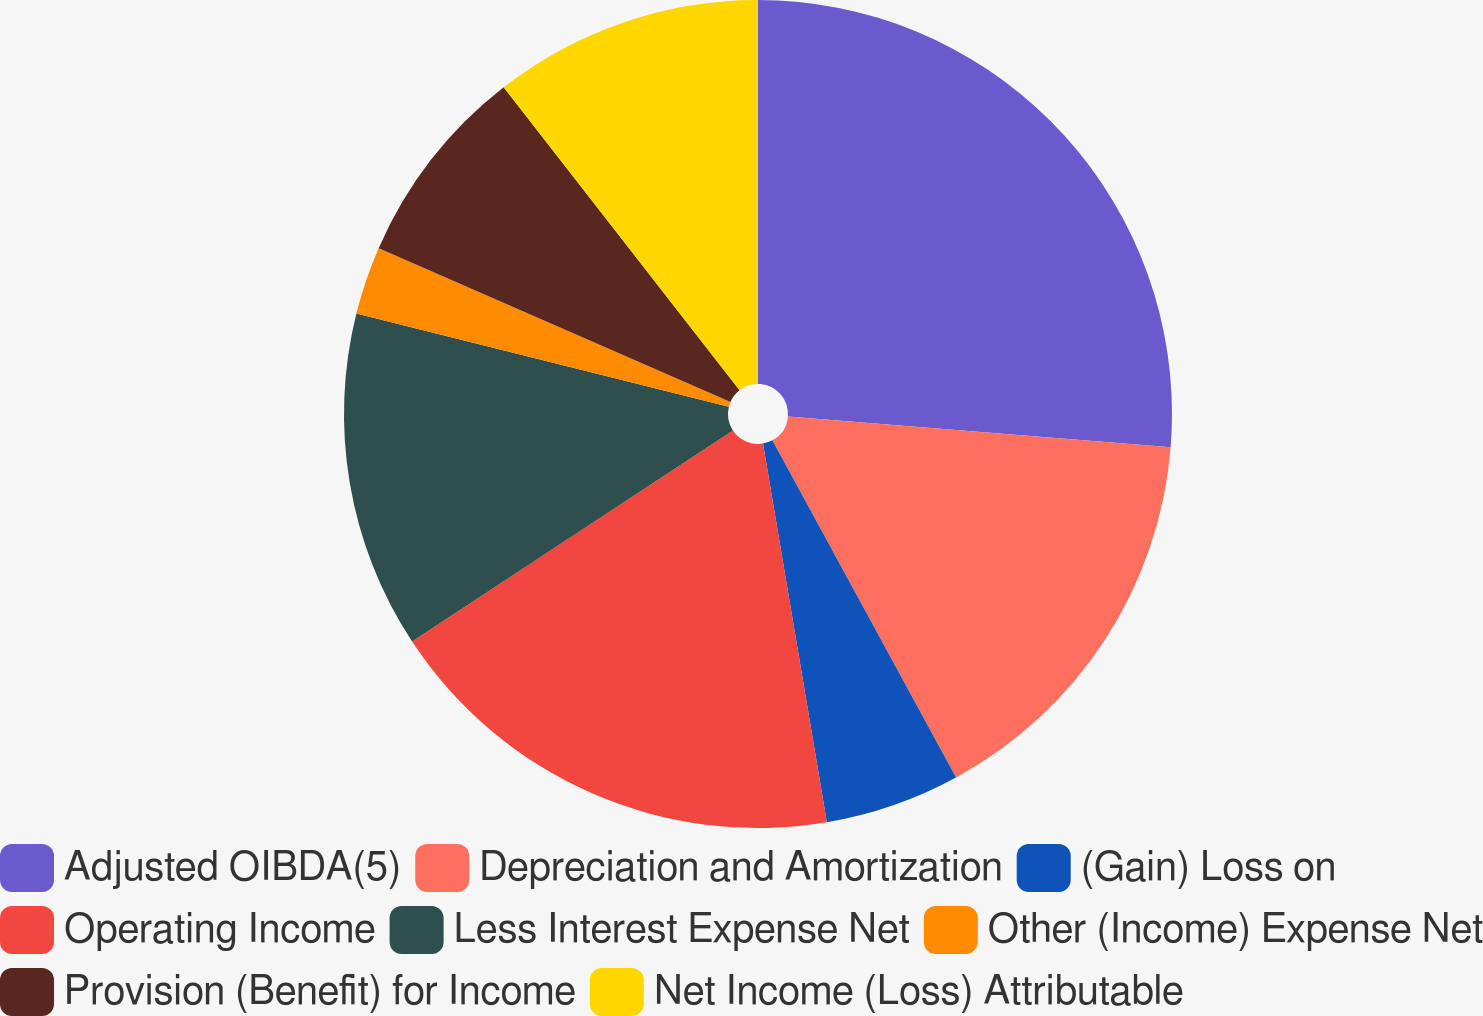<chart> <loc_0><loc_0><loc_500><loc_500><pie_chart><fcel>Adjusted OIBDA(5)<fcel>Depreciation and Amortization<fcel>(Gain) Loss on<fcel>Operating Income<fcel>Less Interest Expense Net<fcel>Other (Income) Expense Net<fcel>Provision (Benefit) for Income<fcel>Net Income (Loss) Attributable<nl><fcel>26.28%<fcel>15.78%<fcel>5.28%<fcel>18.4%<fcel>13.16%<fcel>2.66%<fcel>7.91%<fcel>10.53%<nl></chart> 